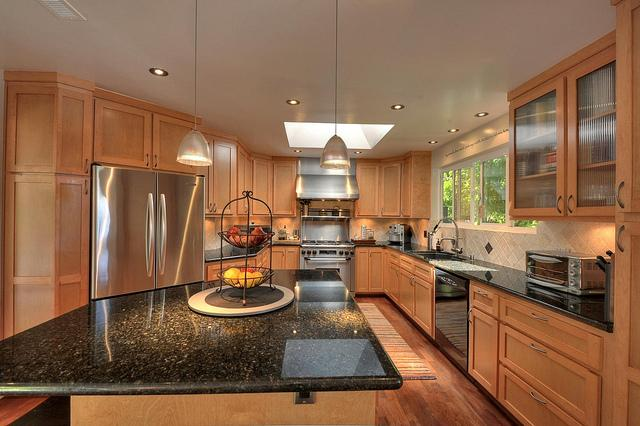What is the countertop in the middle called? Please explain your reasoning. island. The counter is an island. 